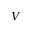Convert formula to latex. <formula><loc_0><loc_0><loc_500><loc_500>V</formula> 